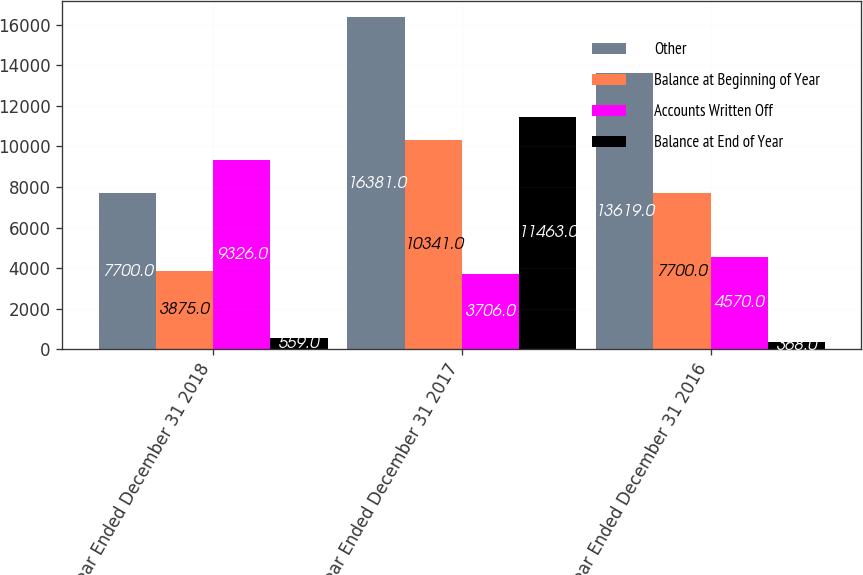<chart> <loc_0><loc_0><loc_500><loc_500><stacked_bar_chart><ecel><fcel>Year Ended December 31 2018<fcel>Year Ended December 31 2017<fcel>Year Ended December 31 2016<nl><fcel>Other<fcel>7700<fcel>16381<fcel>13619<nl><fcel>Balance at Beginning of Year<fcel>3875<fcel>10341<fcel>7700<nl><fcel>Accounts Written Off<fcel>9326<fcel>3706<fcel>4570<nl><fcel>Balance at End of Year<fcel>559<fcel>11463<fcel>368<nl></chart> 